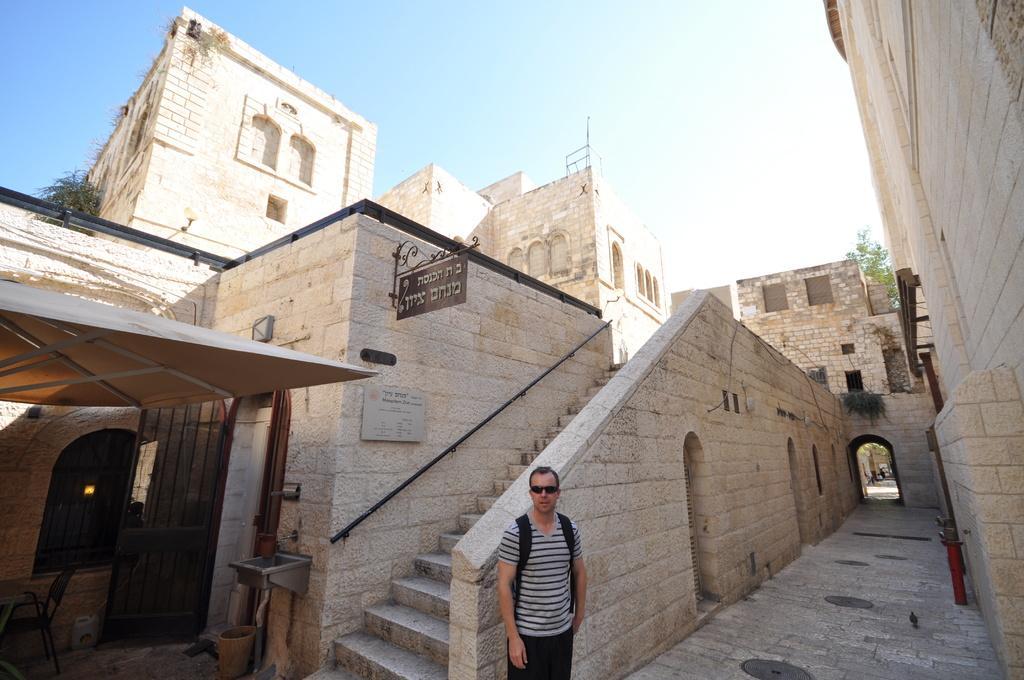Please provide a concise description of this image. In the picture there is a man standing in the foreground and behind the man there is an architecture. 